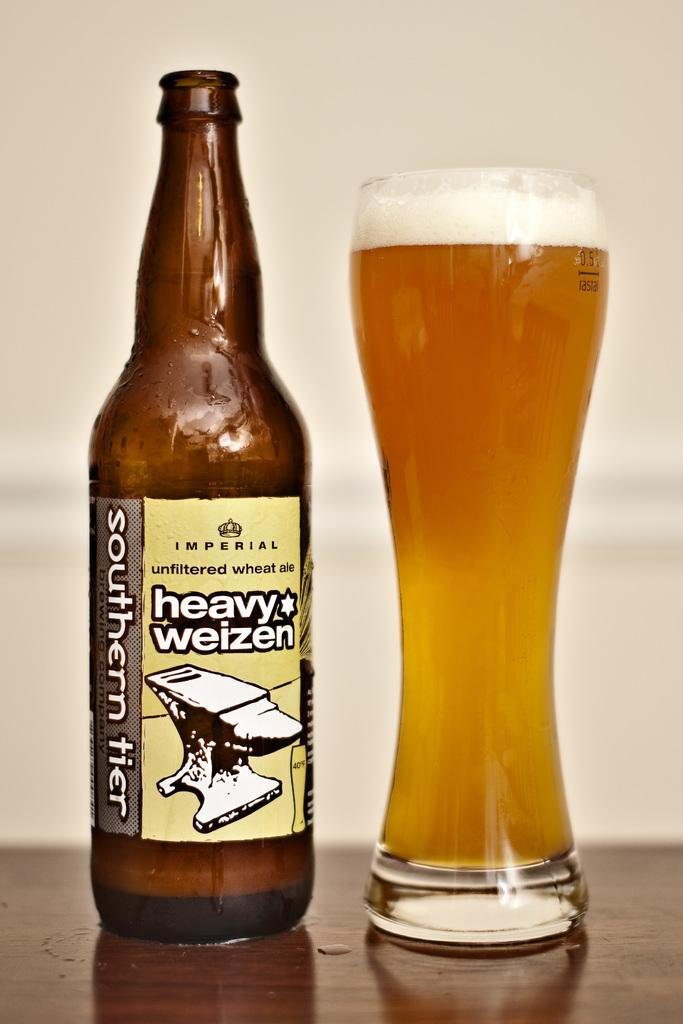<image>
Offer a succinct explanation of the picture presented. a glass and bottle of Southern Tier Heavy Weizen 